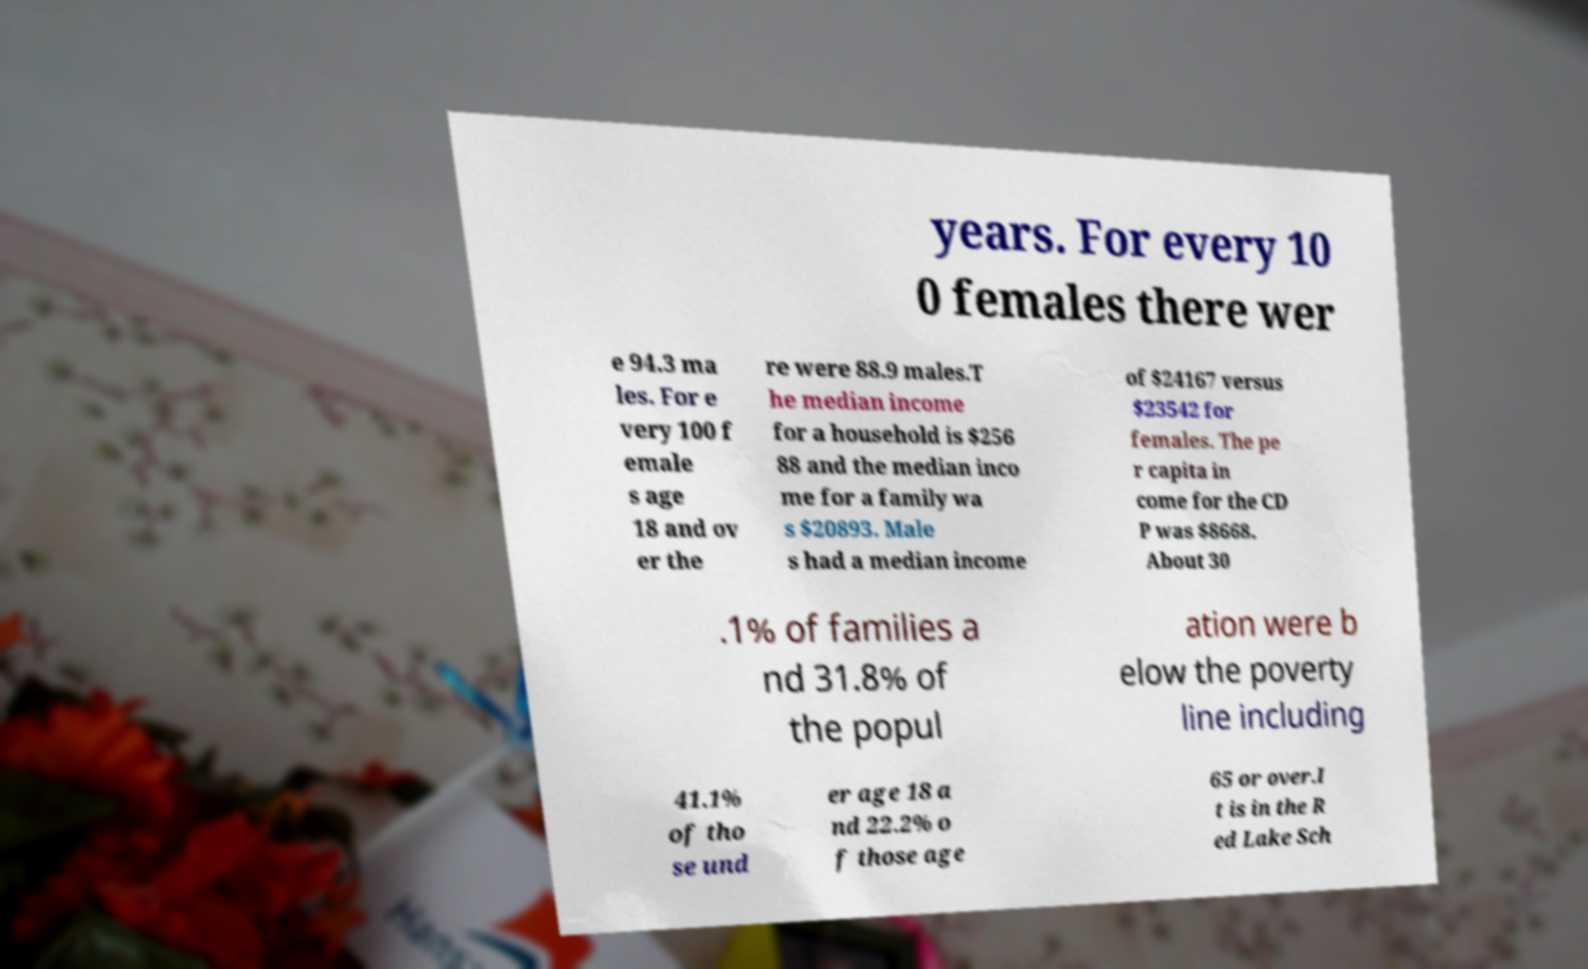What messages or text are displayed in this image? I need them in a readable, typed format. years. For every 10 0 females there wer e 94.3 ma les. For e very 100 f emale s age 18 and ov er the re were 88.9 males.T he median income for a household is $256 88 and the median inco me for a family wa s $20893. Male s had a median income of $24167 versus $23542 for females. The pe r capita in come for the CD P was $8668. About 30 .1% of families a nd 31.8% of the popul ation were b elow the poverty line including 41.1% of tho se und er age 18 a nd 22.2% o f those age 65 or over.I t is in the R ed Lake Sch 